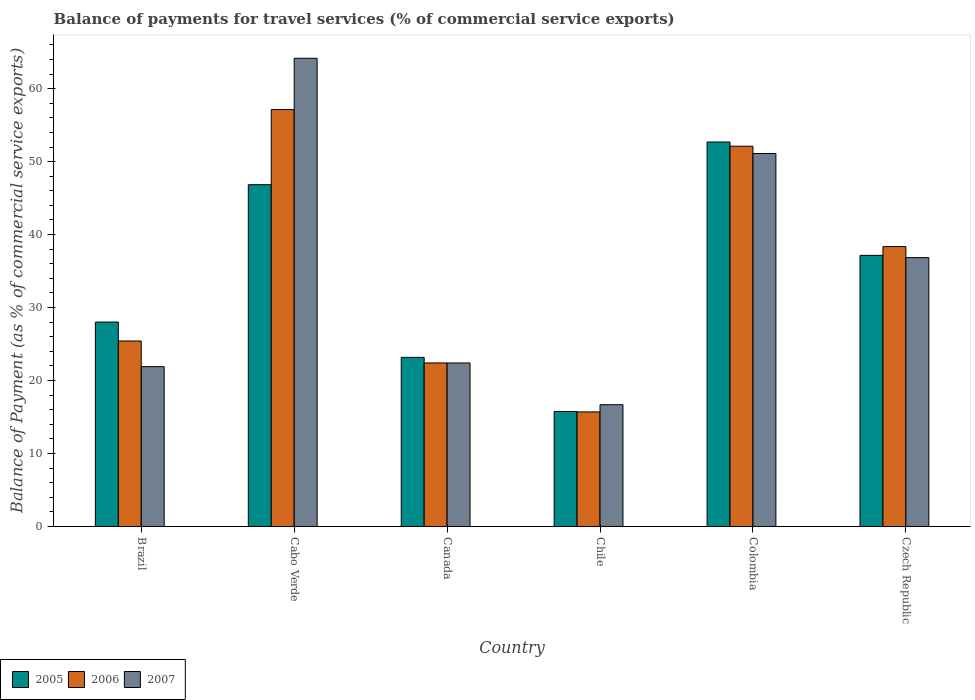How many groups of bars are there?
Keep it short and to the point. 6. Are the number of bars on each tick of the X-axis equal?
Make the answer very short. Yes. How many bars are there on the 3rd tick from the left?
Offer a terse response. 3. What is the label of the 6th group of bars from the left?
Keep it short and to the point. Czech Republic. In how many cases, is the number of bars for a given country not equal to the number of legend labels?
Provide a succinct answer. 0. What is the balance of payments for travel services in 2007 in Brazil?
Provide a succinct answer. 21.9. Across all countries, what is the maximum balance of payments for travel services in 2007?
Provide a short and direct response. 64.16. Across all countries, what is the minimum balance of payments for travel services in 2005?
Your answer should be compact. 15.75. In which country was the balance of payments for travel services in 2006 maximum?
Your answer should be compact. Cabo Verde. What is the total balance of payments for travel services in 2007 in the graph?
Your answer should be very brief. 213.11. What is the difference between the balance of payments for travel services in 2006 in Brazil and that in Colombia?
Make the answer very short. -26.69. What is the difference between the balance of payments for travel services in 2006 in Cabo Verde and the balance of payments for travel services in 2005 in Chile?
Make the answer very short. 41.38. What is the average balance of payments for travel services in 2005 per country?
Make the answer very short. 33.94. What is the difference between the balance of payments for travel services of/in 2007 and balance of payments for travel services of/in 2005 in Brazil?
Your answer should be compact. -6.11. In how many countries, is the balance of payments for travel services in 2005 greater than 12 %?
Your answer should be compact. 6. What is the ratio of the balance of payments for travel services in 2007 in Cabo Verde to that in Czech Republic?
Offer a very short reply. 1.74. Is the balance of payments for travel services in 2007 in Canada less than that in Chile?
Provide a succinct answer. No. What is the difference between the highest and the second highest balance of payments for travel services in 2006?
Your answer should be very brief. 5.02. What is the difference between the highest and the lowest balance of payments for travel services in 2006?
Give a very brief answer. 41.43. In how many countries, is the balance of payments for travel services in 2007 greater than the average balance of payments for travel services in 2007 taken over all countries?
Your answer should be very brief. 3. Is the sum of the balance of payments for travel services in 2005 in Cabo Verde and Chile greater than the maximum balance of payments for travel services in 2007 across all countries?
Your answer should be compact. No. What does the 2nd bar from the right in Brazil represents?
Give a very brief answer. 2006. How many bars are there?
Ensure brevity in your answer.  18. Are the values on the major ticks of Y-axis written in scientific E-notation?
Keep it short and to the point. No. Where does the legend appear in the graph?
Make the answer very short. Bottom left. How many legend labels are there?
Keep it short and to the point. 3. How are the legend labels stacked?
Offer a terse response. Horizontal. What is the title of the graph?
Ensure brevity in your answer.  Balance of payments for travel services (% of commercial service exports). Does "1987" appear as one of the legend labels in the graph?
Your answer should be compact. No. What is the label or title of the Y-axis?
Offer a very short reply. Balance of Payment (as % of commercial service exports). What is the Balance of Payment (as % of commercial service exports) of 2005 in Brazil?
Ensure brevity in your answer.  28.01. What is the Balance of Payment (as % of commercial service exports) in 2006 in Brazil?
Offer a very short reply. 25.42. What is the Balance of Payment (as % of commercial service exports) of 2007 in Brazil?
Your response must be concise. 21.9. What is the Balance of Payment (as % of commercial service exports) in 2005 in Cabo Verde?
Offer a very short reply. 46.84. What is the Balance of Payment (as % of commercial service exports) of 2006 in Cabo Verde?
Give a very brief answer. 57.13. What is the Balance of Payment (as % of commercial service exports) in 2007 in Cabo Verde?
Your answer should be compact. 64.16. What is the Balance of Payment (as % of commercial service exports) of 2005 in Canada?
Offer a terse response. 23.17. What is the Balance of Payment (as % of commercial service exports) of 2006 in Canada?
Offer a very short reply. 22.41. What is the Balance of Payment (as % of commercial service exports) in 2007 in Canada?
Offer a very short reply. 22.41. What is the Balance of Payment (as % of commercial service exports) in 2005 in Chile?
Your answer should be very brief. 15.75. What is the Balance of Payment (as % of commercial service exports) of 2006 in Chile?
Make the answer very short. 15.7. What is the Balance of Payment (as % of commercial service exports) of 2007 in Chile?
Your answer should be very brief. 16.69. What is the Balance of Payment (as % of commercial service exports) of 2005 in Colombia?
Your response must be concise. 52.69. What is the Balance of Payment (as % of commercial service exports) in 2006 in Colombia?
Provide a short and direct response. 52.11. What is the Balance of Payment (as % of commercial service exports) in 2007 in Colombia?
Provide a short and direct response. 51.11. What is the Balance of Payment (as % of commercial service exports) of 2005 in Czech Republic?
Your response must be concise. 37.15. What is the Balance of Payment (as % of commercial service exports) in 2006 in Czech Republic?
Offer a terse response. 38.36. What is the Balance of Payment (as % of commercial service exports) in 2007 in Czech Republic?
Your answer should be very brief. 36.84. Across all countries, what is the maximum Balance of Payment (as % of commercial service exports) of 2005?
Offer a terse response. 52.69. Across all countries, what is the maximum Balance of Payment (as % of commercial service exports) in 2006?
Provide a succinct answer. 57.13. Across all countries, what is the maximum Balance of Payment (as % of commercial service exports) of 2007?
Your answer should be compact. 64.16. Across all countries, what is the minimum Balance of Payment (as % of commercial service exports) of 2005?
Offer a very short reply. 15.75. Across all countries, what is the minimum Balance of Payment (as % of commercial service exports) in 2006?
Provide a succinct answer. 15.7. Across all countries, what is the minimum Balance of Payment (as % of commercial service exports) in 2007?
Your answer should be compact. 16.69. What is the total Balance of Payment (as % of commercial service exports) in 2005 in the graph?
Provide a short and direct response. 203.62. What is the total Balance of Payment (as % of commercial service exports) of 2006 in the graph?
Keep it short and to the point. 211.13. What is the total Balance of Payment (as % of commercial service exports) in 2007 in the graph?
Offer a very short reply. 213.11. What is the difference between the Balance of Payment (as % of commercial service exports) of 2005 in Brazil and that in Cabo Verde?
Provide a short and direct response. -18.82. What is the difference between the Balance of Payment (as % of commercial service exports) of 2006 in Brazil and that in Cabo Verde?
Offer a very short reply. -31.71. What is the difference between the Balance of Payment (as % of commercial service exports) of 2007 in Brazil and that in Cabo Verde?
Keep it short and to the point. -42.26. What is the difference between the Balance of Payment (as % of commercial service exports) in 2005 in Brazil and that in Canada?
Make the answer very short. 4.84. What is the difference between the Balance of Payment (as % of commercial service exports) in 2006 in Brazil and that in Canada?
Your response must be concise. 3.01. What is the difference between the Balance of Payment (as % of commercial service exports) in 2007 in Brazil and that in Canada?
Provide a succinct answer. -0.51. What is the difference between the Balance of Payment (as % of commercial service exports) in 2005 in Brazil and that in Chile?
Give a very brief answer. 12.26. What is the difference between the Balance of Payment (as % of commercial service exports) in 2006 in Brazil and that in Chile?
Your response must be concise. 9.72. What is the difference between the Balance of Payment (as % of commercial service exports) in 2007 in Brazil and that in Chile?
Keep it short and to the point. 5.21. What is the difference between the Balance of Payment (as % of commercial service exports) in 2005 in Brazil and that in Colombia?
Make the answer very short. -24.67. What is the difference between the Balance of Payment (as % of commercial service exports) of 2006 in Brazil and that in Colombia?
Your answer should be compact. -26.69. What is the difference between the Balance of Payment (as % of commercial service exports) of 2007 in Brazil and that in Colombia?
Make the answer very short. -29.21. What is the difference between the Balance of Payment (as % of commercial service exports) in 2005 in Brazil and that in Czech Republic?
Keep it short and to the point. -9.14. What is the difference between the Balance of Payment (as % of commercial service exports) of 2006 in Brazil and that in Czech Republic?
Offer a very short reply. -12.94. What is the difference between the Balance of Payment (as % of commercial service exports) of 2007 in Brazil and that in Czech Republic?
Ensure brevity in your answer.  -14.94. What is the difference between the Balance of Payment (as % of commercial service exports) of 2005 in Cabo Verde and that in Canada?
Your answer should be compact. 23.66. What is the difference between the Balance of Payment (as % of commercial service exports) in 2006 in Cabo Verde and that in Canada?
Keep it short and to the point. 34.72. What is the difference between the Balance of Payment (as % of commercial service exports) in 2007 in Cabo Verde and that in Canada?
Offer a very short reply. 41.75. What is the difference between the Balance of Payment (as % of commercial service exports) in 2005 in Cabo Verde and that in Chile?
Provide a short and direct response. 31.08. What is the difference between the Balance of Payment (as % of commercial service exports) in 2006 in Cabo Verde and that in Chile?
Provide a succinct answer. 41.43. What is the difference between the Balance of Payment (as % of commercial service exports) of 2007 in Cabo Verde and that in Chile?
Your response must be concise. 47.47. What is the difference between the Balance of Payment (as % of commercial service exports) in 2005 in Cabo Verde and that in Colombia?
Ensure brevity in your answer.  -5.85. What is the difference between the Balance of Payment (as % of commercial service exports) of 2006 in Cabo Verde and that in Colombia?
Provide a short and direct response. 5.02. What is the difference between the Balance of Payment (as % of commercial service exports) in 2007 in Cabo Verde and that in Colombia?
Your answer should be very brief. 13.05. What is the difference between the Balance of Payment (as % of commercial service exports) of 2005 in Cabo Verde and that in Czech Republic?
Your response must be concise. 9.69. What is the difference between the Balance of Payment (as % of commercial service exports) in 2006 in Cabo Verde and that in Czech Republic?
Offer a very short reply. 18.78. What is the difference between the Balance of Payment (as % of commercial service exports) in 2007 in Cabo Verde and that in Czech Republic?
Offer a very short reply. 27.32. What is the difference between the Balance of Payment (as % of commercial service exports) in 2005 in Canada and that in Chile?
Offer a terse response. 7.42. What is the difference between the Balance of Payment (as % of commercial service exports) of 2006 in Canada and that in Chile?
Your response must be concise. 6.71. What is the difference between the Balance of Payment (as % of commercial service exports) in 2007 in Canada and that in Chile?
Provide a short and direct response. 5.72. What is the difference between the Balance of Payment (as % of commercial service exports) of 2005 in Canada and that in Colombia?
Make the answer very short. -29.51. What is the difference between the Balance of Payment (as % of commercial service exports) in 2006 in Canada and that in Colombia?
Give a very brief answer. -29.7. What is the difference between the Balance of Payment (as % of commercial service exports) in 2007 in Canada and that in Colombia?
Give a very brief answer. -28.7. What is the difference between the Balance of Payment (as % of commercial service exports) in 2005 in Canada and that in Czech Republic?
Your response must be concise. -13.98. What is the difference between the Balance of Payment (as % of commercial service exports) in 2006 in Canada and that in Czech Republic?
Ensure brevity in your answer.  -15.94. What is the difference between the Balance of Payment (as % of commercial service exports) of 2007 in Canada and that in Czech Republic?
Give a very brief answer. -14.44. What is the difference between the Balance of Payment (as % of commercial service exports) in 2005 in Chile and that in Colombia?
Keep it short and to the point. -36.93. What is the difference between the Balance of Payment (as % of commercial service exports) in 2006 in Chile and that in Colombia?
Your answer should be compact. -36.41. What is the difference between the Balance of Payment (as % of commercial service exports) of 2007 in Chile and that in Colombia?
Ensure brevity in your answer.  -34.42. What is the difference between the Balance of Payment (as % of commercial service exports) in 2005 in Chile and that in Czech Republic?
Provide a short and direct response. -21.4. What is the difference between the Balance of Payment (as % of commercial service exports) in 2006 in Chile and that in Czech Republic?
Offer a very short reply. -22.66. What is the difference between the Balance of Payment (as % of commercial service exports) in 2007 in Chile and that in Czech Republic?
Your answer should be compact. -20.15. What is the difference between the Balance of Payment (as % of commercial service exports) in 2005 in Colombia and that in Czech Republic?
Give a very brief answer. 15.53. What is the difference between the Balance of Payment (as % of commercial service exports) of 2006 in Colombia and that in Czech Republic?
Ensure brevity in your answer.  13.76. What is the difference between the Balance of Payment (as % of commercial service exports) of 2007 in Colombia and that in Czech Republic?
Your answer should be very brief. 14.27. What is the difference between the Balance of Payment (as % of commercial service exports) in 2005 in Brazil and the Balance of Payment (as % of commercial service exports) in 2006 in Cabo Verde?
Offer a terse response. -29.12. What is the difference between the Balance of Payment (as % of commercial service exports) in 2005 in Brazil and the Balance of Payment (as % of commercial service exports) in 2007 in Cabo Verde?
Make the answer very short. -36.15. What is the difference between the Balance of Payment (as % of commercial service exports) of 2006 in Brazil and the Balance of Payment (as % of commercial service exports) of 2007 in Cabo Verde?
Make the answer very short. -38.74. What is the difference between the Balance of Payment (as % of commercial service exports) in 2005 in Brazil and the Balance of Payment (as % of commercial service exports) in 2006 in Canada?
Make the answer very short. 5.6. What is the difference between the Balance of Payment (as % of commercial service exports) of 2005 in Brazil and the Balance of Payment (as % of commercial service exports) of 2007 in Canada?
Offer a very short reply. 5.61. What is the difference between the Balance of Payment (as % of commercial service exports) in 2006 in Brazil and the Balance of Payment (as % of commercial service exports) in 2007 in Canada?
Provide a succinct answer. 3.01. What is the difference between the Balance of Payment (as % of commercial service exports) of 2005 in Brazil and the Balance of Payment (as % of commercial service exports) of 2006 in Chile?
Your answer should be compact. 12.31. What is the difference between the Balance of Payment (as % of commercial service exports) of 2005 in Brazil and the Balance of Payment (as % of commercial service exports) of 2007 in Chile?
Your answer should be compact. 11.32. What is the difference between the Balance of Payment (as % of commercial service exports) of 2006 in Brazil and the Balance of Payment (as % of commercial service exports) of 2007 in Chile?
Your answer should be compact. 8.73. What is the difference between the Balance of Payment (as % of commercial service exports) of 2005 in Brazil and the Balance of Payment (as % of commercial service exports) of 2006 in Colombia?
Keep it short and to the point. -24.1. What is the difference between the Balance of Payment (as % of commercial service exports) in 2005 in Brazil and the Balance of Payment (as % of commercial service exports) in 2007 in Colombia?
Keep it short and to the point. -23.1. What is the difference between the Balance of Payment (as % of commercial service exports) in 2006 in Brazil and the Balance of Payment (as % of commercial service exports) in 2007 in Colombia?
Keep it short and to the point. -25.69. What is the difference between the Balance of Payment (as % of commercial service exports) in 2005 in Brazil and the Balance of Payment (as % of commercial service exports) in 2006 in Czech Republic?
Offer a very short reply. -10.34. What is the difference between the Balance of Payment (as % of commercial service exports) of 2005 in Brazil and the Balance of Payment (as % of commercial service exports) of 2007 in Czech Republic?
Keep it short and to the point. -8.83. What is the difference between the Balance of Payment (as % of commercial service exports) of 2006 in Brazil and the Balance of Payment (as % of commercial service exports) of 2007 in Czech Republic?
Your response must be concise. -11.42. What is the difference between the Balance of Payment (as % of commercial service exports) in 2005 in Cabo Verde and the Balance of Payment (as % of commercial service exports) in 2006 in Canada?
Offer a very short reply. 24.43. What is the difference between the Balance of Payment (as % of commercial service exports) of 2005 in Cabo Verde and the Balance of Payment (as % of commercial service exports) of 2007 in Canada?
Offer a terse response. 24.43. What is the difference between the Balance of Payment (as % of commercial service exports) in 2006 in Cabo Verde and the Balance of Payment (as % of commercial service exports) in 2007 in Canada?
Offer a terse response. 34.72. What is the difference between the Balance of Payment (as % of commercial service exports) of 2005 in Cabo Verde and the Balance of Payment (as % of commercial service exports) of 2006 in Chile?
Your response must be concise. 31.14. What is the difference between the Balance of Payment (as % of commercial service exports) of 2005 in Cabo Verde and the Balance of Payment (as % of commercial service exports) of 2007 in Chile?
Offer a very short reply. 30.15. What is the difference between the Balance of Payment (as % of commercial service exports) of 2006 in Cabo Verde and the Balance of Payment (as % of commercial service exports) of 2007 in Chile?
Keep it short and to the point. 40.44. What is the difference between the Balance of Payment (as % of commercial service exports) in 2005 in Cabo Verde and the Balance of Payment (as % of commercial service exports) in 2006 in Colombia?
Offer a very short reply. -5.27. What is the difference between the Balance of Payment (as % of commercial service exports) of 2005 in Cabo Verde and the Balance of Payment (as % of commercial service exports) of 2007 in Colombia?
Make the answer very short. -4.27. What is the difference between the Balance of Payment (as % of commercial service exports) in 2006 in Cabo Verde and the Balance of Payment (as % of commercial service exports) in 2007 in Colombia?
Make the answer very short. 6.02. What is the difference between the Balance of Payment (as % of commercial service exports) in 2005 in Cabo Verde and the Balance of Payment (as % of commercial service exports) in 2006 in Czech Republic?
Provide a short and direct response. 8.48. What is the difference between the Balance of Payment (as % of commercial service exports) in 2005 in Cabo Verde and the Balance of Payment (as % of commercial service exports) in 2007 in Czech Republic?
Give a very brief answer. 9.99. What is the difference between the Balance of Payment (as % of commercial service exports) in 2006 in Cabo Verde and the Balance of Payment (as % of commercial service exports) in 2007 in Czech Republic?
Offer a very short reply. 20.29. What is the difference between the Balance of Payment (as % of commercial service exports) in 2005 in Canada and the Balance of Payment (as % of commercial service exports) in 2006 in Chile?
Provide a short and direct response. 7.47. What is the difference between the Balance of Payment (as % of commercial service exports) of 2005 in Canada and the Balance of Payment (as % of commercial service exports) of 2007 in Chile?
Ensure brevity in your answer.  6.48. What is the difference between the Balance of Payment (as % of commercial service exports) of 2006 in Canada and the Balance of Payment (as % of commercial service exports) of 2007 in Chile?
Your answer should be very brief. 5.72. What is the difference between the Balance of Payment (as % of commercial service exports) in 2005 in Canada and the Balance of Payment (as % of commercial service exports) in 2006 in Colombia?
Make the answer very short. -28.94. What is the difference between the Balance of Payment (as % of commercial service exports) in 2005 in Canada and the Balance of Payment (as % of commercial service exports) in 2007 in Colombia?
Make the answer very short. -27.94. What is the difference between the Balance of Payment (as % of commercial service exports) in 2006 in Canada and the Balance of Payment (as % of commercial service exports) in 2007 in Colombia?
Offer a terse response. -28.7. What is the difference between the Balance of Payment (as % of commercial service exports) of 2005 in Canada and the Balance of Payment (as % of commercial service exports) of 2006 in Czech Republic?
Your response must be concise. -15.18. What is the difference between the Balance of Payment (as % of commercial service exports) in 2005 in Canada and the Balance of Payment (as % of commercial service exports) in 2007 in Czech Republic?
Your answer should be compact. -13.67. What is the difference between the Balance of Payment (as % of commercial service exports) of 2006 in Canada and the Balance of Payment (as % of commercial service exports) of 2007 in Czech Republic?
Your answer should be compact. -14.43. What is the difference between the Balance of Payment (as % of commercial service exports) of 2005 in Chile and the Balance of Payment (as % of commercial service exports) of 2006 in Colombia?
Offer a terse response. -36.36. What is the difference between the Balance of Payment (as % of commercial service exports) of 2005 in Chile and the Balance of Payment (as % of commercial service exports) of 2007 in Colombia?
Ensure brevity in your answer.  -35.36. What is the difference between the Balance of Payment (as % of commercial service exports) in 2006 in Chile and the Balance of Payment (as % of commercial service exports) in 2007 in Colombia?
Ensure brevity in your answer.  -35.41. What is the difference between the Balance of Payment (as % of commercial service exports) of 2005 in Chile and the Balance of Payment (as % of commercial service exports) of 2006 in Czech Republic?
Offer a very short reply. -22.6. What is the difference between the Balance of Payment (as % of commercial service exports) in 2005 in Chile and the Balance of Payment (as % of commercial service exports) in 2007 in Czech Republic?
Make the answer very short. -21.09. What is the difference between the Balance of Payment (as % of commercial service exports) in 2006 in Chile and the Balance of Payment (as % of commercial service exports) in 2007 in Czech Republic?
Your answer should be compact. -21.14. What is the difference between the Balance of Payment (as % of commercial service exports) in 2005 in Colombia and the Balance of Payment (as % of commercial service exports) in 2006 in Czech Republic?
Ensure brevity in your answer.  14.33. What is the difference between the Balance of Payment (as % of commercial service exports) in 2005 in Colombia and the Balance of Payment (as % of commercial service exports) in 2007 in Czech Republic?
Offer a very short reply. 15.84. What is the difference between the Balance of Payment (as % of commercial service exports) in 2006 in Colombia and the Balance of Payment (as % of commercial service exports) in 2007 in Czech Republic?
Your response must be concise. 15.27. What is the average Balance of Payment (as % of commercial service exports) in 2005 per country?
Make the answer very short. 33.94. What is the average Balance of Payment (as % of commercial service exports) in 2006 per country?
Provide a short and direct response. 35.19. What is the average Balance of Payment (as % of commercial service exports) of 2007 per country?
Give a very brief answer. 35.52. What is the difference between the Balance of Payment (as % of commercial service exports) in 2005 and Balance of Payment (as % of commercial service exports) in 2006 in Brazil?
Provide a succinct answer. 2.59. What is the difference between the Balance of Payment (as % of commercial service exports) in 2005 and Balance of Payment (as % of commercial service exports) in 2007 in Brazil?
Offer a terse response. 6.11. What is the difference between the Balance of Payment (as % of commercial service exports) in 2006 and Balance of Payment (as % of commercial service exports) in 2007 in Brazil?
Your answer should be compact. 3.52. What is the difference between the Balance of Payment (as % of commercial service exports) in 2005 and Balance of Payment (as % of commercial service exports) in 2006 in Cabo Verde?
Your answer should be very brief. -10.29. What is the difference between the Balance of Payment (as % of commercial service exports) of 2005 and Balance of Payment (as % of commercial service exports) of 2007 in Cabo Verde?
Provide a succinct answer. -17.32. What is the difference between the Balance of Payment (as % of commercial service exports) in 2006 and Balance of Payment (as % of commercial service exports) in 2007 in Cabo Verde?
Provide a succinct answer. -7.03. What is the difference between the Balance of Payment (as % of commercial service exports) of 2005 and Balance of Payment (as % of commercial service exports) of 2006 in Canada?
Provide a succinct answer. 0.76. What is the difference between the Balance of Payment (as % of commercial service exports) in 2005 and Balance of Payment (as % of commercial service exports) in 2007 in Canada?
Make the answer very short. 0.77. What is the difference between the Balance of Payment (as % of commercial service exports) in 2006 and Balance of Payment (as % of commercial service exports) in 2007 in Canada?
Your answer should be very brief. 0. What is the difference between the Balance of Payment (as % of commercial service exports) of 2005 and Balance of Payment (as % of commercial service exports) of 2006 in Chile?
Offer a very short reply. 0.05. What is the difference between the Balance of Payment (as % of commercial service exports) in 2005 and Balance of Payment (as % of commercial service exports) in 2007 in Chile?
Provide a short and direct response. -0.94. What is the difference between the Balance of Payment (as % of commercial service exports) in 2006 and Balance of Payment (as % of commercial service exports) in 2007 in Chile?
Offer a very short reply. -0.99. What is the difference between the Balance of Payment (as % of commercial service exports) in 2005 and Balance of Payment (as % of commercial service exports) in 2006 in Colombia?
Give a very brief answer. 0.58. What is the difference between the Balance of Payment (as % of commercial service exports) in 2005 and Balance of Payment (as % of commercial service exports) in 2007 in Colombia?
Your answer should be compact. 1.58. What is the difference between the Balance of Payment (as % of commercial service exports) of 2006 and Balance of Payment (as % of commercial service exports) of 2007 in Colombia?
Make the answer very short. 1. What is the difference between the Balance of Payment (as % of commercial service exports) in 2005 and Balance of Payment (as % of commercial service exports) in 2006 in Czech Republic?
Make the answer very short. -1.2. What is the difference between the Balance of Payment (as % of commercial service exports) of 2005 and Balance of Payment (as % of commercial service exports) of 2007 in Czech Republic?
Offer a very short reply. 0.31. What is the difference between the Balance of Payment (as % of commercial service exports) in 2006 and Balance of Payment (as % of commercial service exports) in 2007 in Czech Republic?
Provide a short and direct response. 1.51. What is the ratio of the Balance of Payment (as % of commercial service exports) of 2005 in Brazil to that in Cabo Verde?
Your answer should be very brief. 0.6. What is the ratio of the Balance of Payment (as % of commercial service exports) of 2006 in Brazil to that in Cabo Verde?
Your answer should be very brief. 0.44. What is the ratio of the Balance of Payment (as % of commercial service exports) of 2007 in Brazil to that in Cabo Verde?
Keep it short and to the point. 0.34. What is the ratio of the Balance of Payment (as % of commercial service exports) in 2005 in Brazil to that in Canada?
Keep it short and to the point. 1.21. What is the ratio of the Balance of Payment (as % of commercial service exports) of 2006 in Brazil to that in Canada?
Make the answer very short. 1.13. What is the ratio of the Balance of Payment (as % of commercial service exports) of 2007 in Brazil to that in Canada?
Offer a very short reply. 0.98. What is the ratio of the Balance of Payment (as % of commercial service exports) of 2005 in Brazil to that in Chile?
Offer a very short reply. 1.78. What is the ratio of the Balance of Payment (as % of commercial service exports) of 2006 in Brazil to that in Chile?
Your answer should be very brief. 1.62. What is the ratio of the Balance of Payment (as % of commercial service exports) in 2007 in Brazil to that in Chile?
Give a very brief answer. 1.31. What is the ratio of the Balance of Payment (as % of commercial service exports) of 2005 in Brazil to that in Colombia?
Your answer should be very brief. 0.53. What is the ratio of the Balance of Payment (as % of commercial service exports) of 2006 in Brazil to that in Colombia?
Make the answer very short. 0.49. What is the ratio of the Balance of Payment (as % of commercial service exports) of 2007 in Brazil to that in Colombia?
Keep it short and to the point. 0.43. What is the ratio of the Balance of Payment (as % of commercial service exports) in 2005 in Brazil to that in Czech Republic?
Provide a short and direct response. 0.75. What is the ratio of the Balance of Payment (as % of commercial service exports) of 2006 in Brazil to that in Czech Republic?
Your answer should be very brief. 0.66. What is the ratio of the Balance of Payment (as % of commercial service exports) in 2007 in Brazil to that in Czech Republic?
Your response must be concise. 0.59. What is the ratio of the Balance of Payment (as % of commercial service exports) in 2005 in Cabo Verde to that in Canada?
Keep it short and to the point. 2.02. What is the ratio of the Balance of Payment (as % of commercial service exports) in 2006 in Cabo Verde to that in Canada?
Ensure brevity in your answer.  2.55. What is the ratio of the Balance of Payment (as % of commercial service exports) of 2007 in Cabo Verde to that in Canada?
Your answer should be compact. 2.86. What is the ratio of the Balance of Payment (as % of commercial service exports) in 2005 in Cabo Verde to that in Chile?
Make the answer very short. 2.97. What is the ratio of the Balance of Payment (as % of commercial service exports) of 2006 in Cabo Verde to that in Chile?
Provide a short and direct response. 3.64. What is the ratio of the Balance of Payment (as % of commercial service exports) in 2007 in Cabo Verde to that in Chile?
Keep it short and to the point. 3.84. What is the ratio of the Balance of Payment (as % of commercial service exports) in 2005 in Cabo Verde to that in Colombia?
Offer a terse response. 0.89. What is the ratio of the Balance of Payment (as % of commercial service exports) of 2006 in Cabo Verde to that in Colombia?
Your response must be concise. 1.1. What is the ratio of the Balance of Payment (as % of commercial service exports) of 2007 in Cabo Verde to that in Colombia?
Ensure brevity in your answer.  1.26. What is the ratio of the Balance of Payment (as % of commercial service exports) of 2005 in Cabo Verde to that in Czech Republic?
Your answer should be very brief. 1.26. What is the ratio of the Balance of Payment (as % of commercial service exports) of 2006 in Cabo Verde to that in Czech Republic?
Your answer should be compact. 1.49. What is the ratio of the Balance of Payment (as % of commercial service exports) of 2007 in Cabo Verde to that in Czech Republic?
Ensure brevity in your answer.  1.74. What is the ratio of the Balance of Payment (as % of commercial service exports) in 2005 in Canada to that in Chile?
Provide a succinct answer. 1.47. What is the ratio of the Balance of Payment (as % of commercial service exports) of 2006 in Canada to that in Chile?
Offer a terse response. 1.43. What is the ratio of the Balance of Payment (as % of commercial service exports) in 2007 in Canada to that in Chile?
Your response must be concise. 1.34. What is the ratio of the Balance of Payment (as % of commercial service exports) in 2005 in Canada to that in Colombia?
Give a very brief answer. 0.44. What is the ratio of the Balance of Payment (as % of commercial service exports) of 2006 in Canada to that in Colombia?
Ensure brevity in your answer.  0.43. What is the ratio of the Balance of Payment (as % of commercial service exports) of 2007 in Canada to that in Colombia?
Offer a terse response. 0.44. What is the ratio of the Balance of Payment (as % of commercial service exports) in 2005 in Canada to that in Czech Republic?
Your answer should be very brief. 0.62. What is the ratio of the Balance of Payment (as % of commercial service exports) of 2006 in Canada to that in Czech Republic?
Your answer should be compact. 0.58. What is the ratio of the Balance of Payment (as % of commercial service exports) of 2007 in Canada to that in Czech Republic?
Your answer should be compact. 0.61. What is the ratio of the Balance of Payment (as % of commercial service exports) in 2005 in Chile to that in Colombia?
Your response must be concise. 0.3. What is the ratio of the Balance of Payment (as % of commercial service exports) in 2006 in Chile to that in Colombia?
Provide a short and direct response. 0.3. What is the ratio of the Balance of Payment (as % of commercial service exports) in 2007 in Chile to that in Colombia?
Give a very brief answer. 0.33. What is the ratio of the Balance of Payment (as % of commercial service exports) of 2005 in Chile to that in Czech Republic?
Keep it short and to the point. 0.42. What is the ratio of the Balance of Payment (as % of commercial service exports) of 2006 in Chile to that in Czech Republic?
Your response must be concise. 0.41. What is the ratio of the Balance of Payment (as % of commercial service exports) of 2007 in Chile to that in Czech Republic?
Your response must be concise. 0.45. What is the ratio of the Balance of Payment (as % of commercial service exports) of 2005 in Colombia to that in Czech Republic?
Your response must be concise. 1.42. What is the ratio of the Balance of Payment (as % of commercial service exports) of 2006 in Colombia to that in Czech Republic?
Offer a terse response. 1.36. What is the ratio of the Balance of Payment (as % of commercial service exports) in 2007 in Colombia to that in Czech Republic?
Your answer should be very brief. 1.39. What is the difference between the highest and the second highest Balance of Payment (as % of commercial service exports) in 2005?
Give a very brief answer. 5.85. What is the difference between the highest and the second highest Balance of Payment (as % of commercial service exports) of 2006?
Provide a short and direct response. 5.02. What is the difference between the highest and the second highest Balance of Payment (as % of commercial service exports) in 2007?
Provide a short and direct response. 13.05. What is the difference between the highest and the lowest Balance of Payment (as % of commercial service exports) in 2005?
Ensure brevity in your answer.  36.93. What is the difference between the highest and the lowest Balance of Payment (as % of commercial service exports) in 2006?
Give a very brief answer. 41.43. What is the difference between the highest and the lowest Balance of Payment (as % of commercial service exports) in 2007?
Provide a short and direct response. 47.47. 